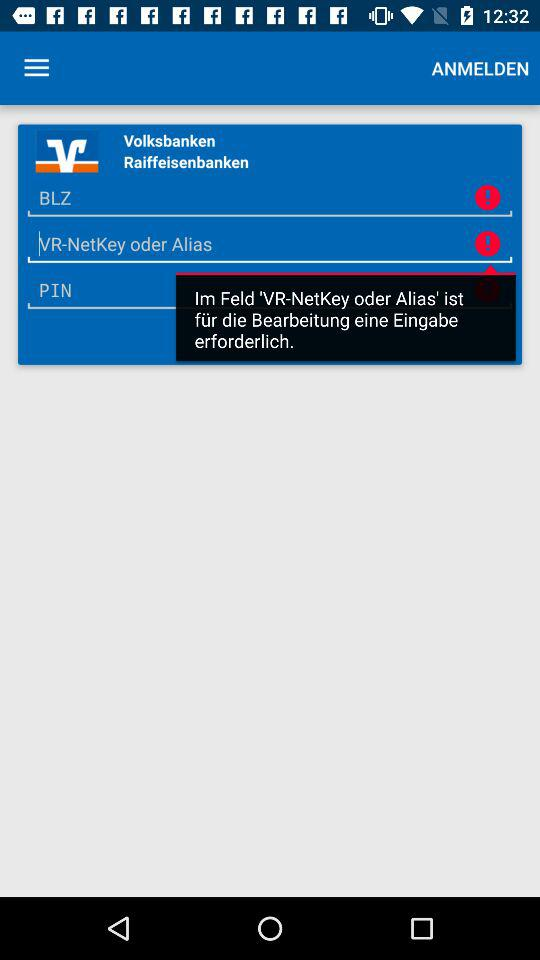How many red exclamation marks are on the screen?
Answer the question using a single word or phrase. 2 